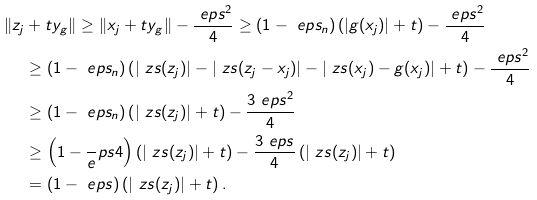<formula> <loc_0><loc_0><loc_500><loc_500>\| z _ { j } & + t y _ { g } \| \geq \| x _ { j } + t y _ { g } \| - \frac { \ e p s ^ { 2 } } 4 \geq ( 1 - \ e p s _ { n } ) \left ( | g ( x _ { j } ) | + t \right ) - \frac { \ e p s ^ { 2 } } 4 \\ & \geq ( 1 - \ e p s _ { n } ) \left ( | \ z s ( z _ { j } ) | - | \ z s ( z _ { j } - x _ { j } ) | - | \ z s ( x _ { j } ) - g ( x _ { j } ) | + t \right ) - \frac { \ e p s ^ { 2 } } 4 \\ & \geq ( 1 - \ e p s _ { n } ) \left ( | \ z s ( z _ { j } ) | + t \right ) - \frac { 3 \ e p s ^ { 2 } } 4 \\ & \geq \left ( 1 - \frac { \ } { e } p s 4 \right ) \left ( | \ z s ( z _ { j } ) | + t \right ) - \frac { 3 \ e p s } 4 \left ( | \ z s ( z _ { j } ) | + t \right ) \\ & = ( 1 - \ e p s ) \left ( | \ z s ( z _ { j } ) | + t \right ) .</formula> 